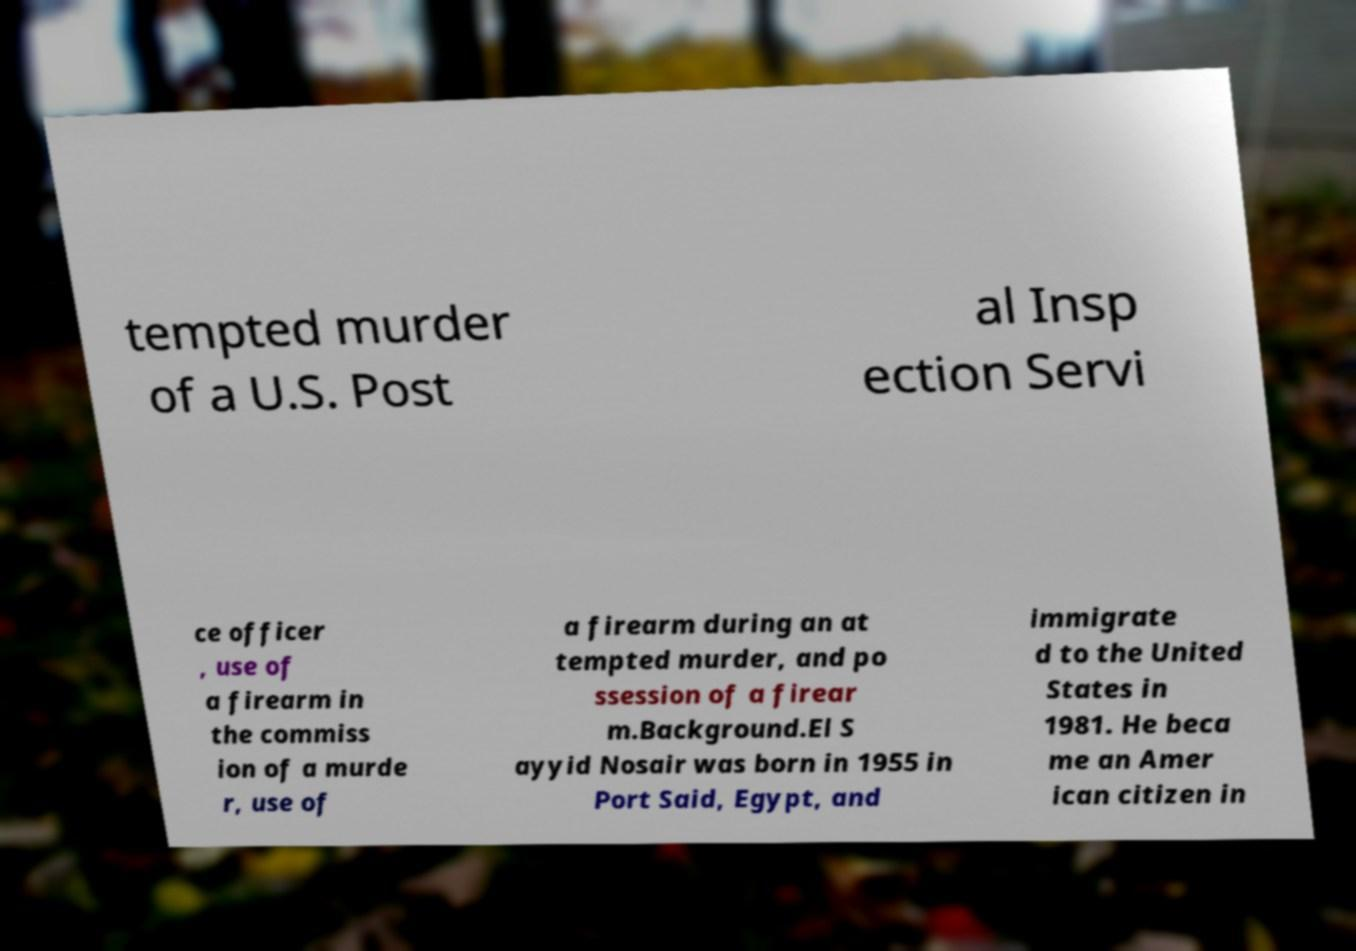Can you read and provide the text displayed in the image?This photo seems to have some interesting text. Can you extract and type it out for me? tempted murder of a U.S. Post al Insp ection Servi ce officer , use of a firearm in the commiss ion of a murde r, use of a firearm during an at tempted murder, and po ssession of a firear m.Background.El S ayyid Nosair was born in 1955 in Port Said, Egypt, and immigrate d to the United States in 1981. He beca me an Amer ican citizen in 